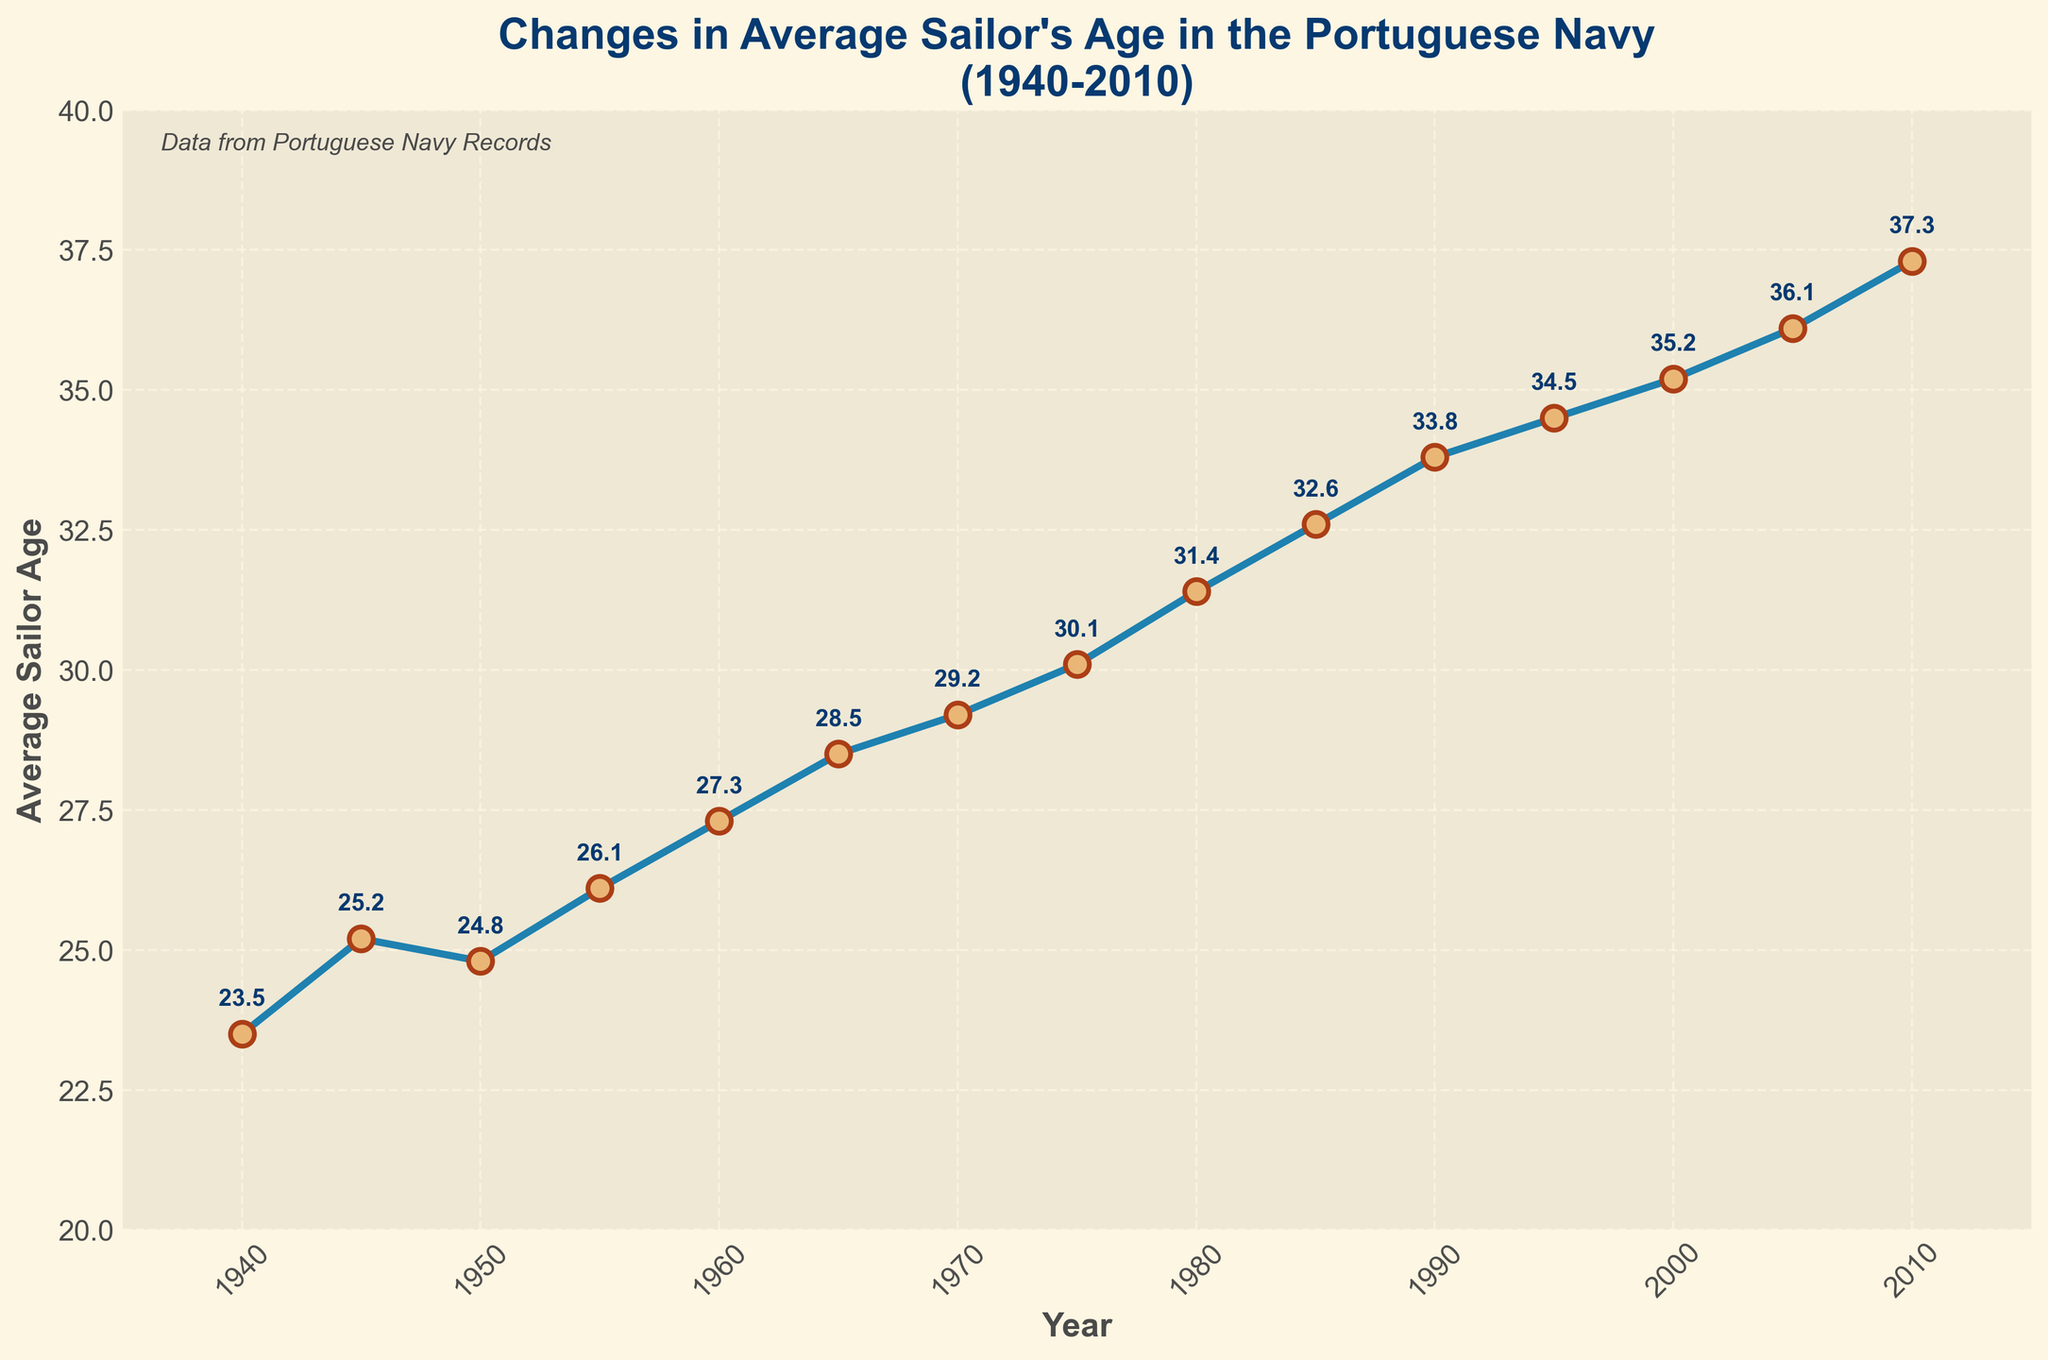What is the average sailor's age in 1955? Locate the point corresponding to 1955 on the x-axis and read the value on the y-axis, which represents the average sailor's age.
Answer: 26.1 Between which years does the largest increase in the average sailor's age occur? Inspect the plot to find the interval with the steepest slope. Identify the years at the beginning and end of this interval.
Answer: 1945 to 1945 How much did the average sailor's age increase from 1940 to 1980? Subtract the average sailor's age in 1940 (23.5) from the average sailor's age in 1980 (31.4).
Answer: 7.9 Between 1965 and 1990, by how many years did the average sailor's age increase? Subtract the average sailor's age in 1965 (28.5) from the average sailor's age in 1990 (33.8).
Answer: 5.3 In which decade did the average sailor's age surpass 30 years for the first time? Inspect the plot to identify the first point where the y-axis value exceeds 30, then find the corresponding decade.
Answer: 1970-1980 Compare the increase in average sailor's age between the 1950s and the 1990s. Which decade saw a larger increase? Calculate the change in average sailor's age for both decades: 1950-1960 (27.3-24.8=2.5) and 1990-2000 (35.2-33.8=1.4). Compare the two values.
Answer: 1950s What is the rate of increase in the average sailor's age from 2000 to 2010? Subtract the average sailor's age in 2000 (35.2) from the average sailor's age in 2010 (37.3) and then divide by the number of years (10).
Answer: 0.21 per year Which year has the lowest average sailor's age, and what is that age? Identify the point with the minimum y-axis value and note the corresponding year and value.
Answer: 1940, 23.5 How does the average sailor's age in 2000 compare to that in 1940? Compare the average sailor's ages in 2000 (35.2) and 1940 (23.5) to determine which is higher.
Answer: 2000 was higher 